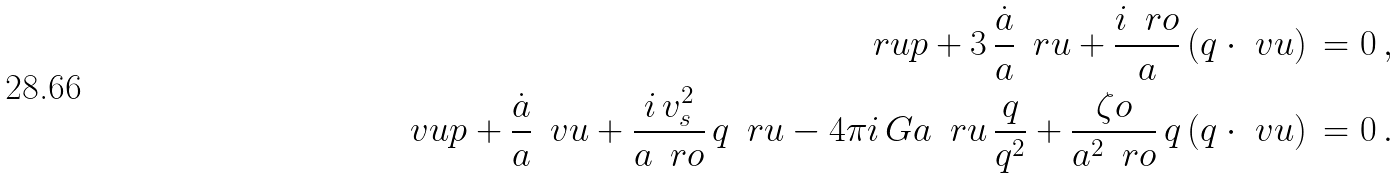<formula> <loc_0><loc_0><loc_500><loc_500>\ r u p + 3 \, \frac { \dot { a } } { a } \, \ r u + \frac { i \, \ r o } { a } \, ( q \cdot \ v u ) \, & = 0 \, , \\ \quad \, \ v u p + \frac { \dot { a } } { a } \, \ v u + \frac { i \, v _ { s } ^ { 2 } } { a \, \ r o } \, q \, \ r u - 4 \pi i \, G a \, \ r u \, \frac { q } { q ^ { 2 } } + \frac { \zeta o } { a ^ { 2 } \, \ r o } \, q \, ( q \cdot \ v u ) \, & = 0 \, .</formula> 